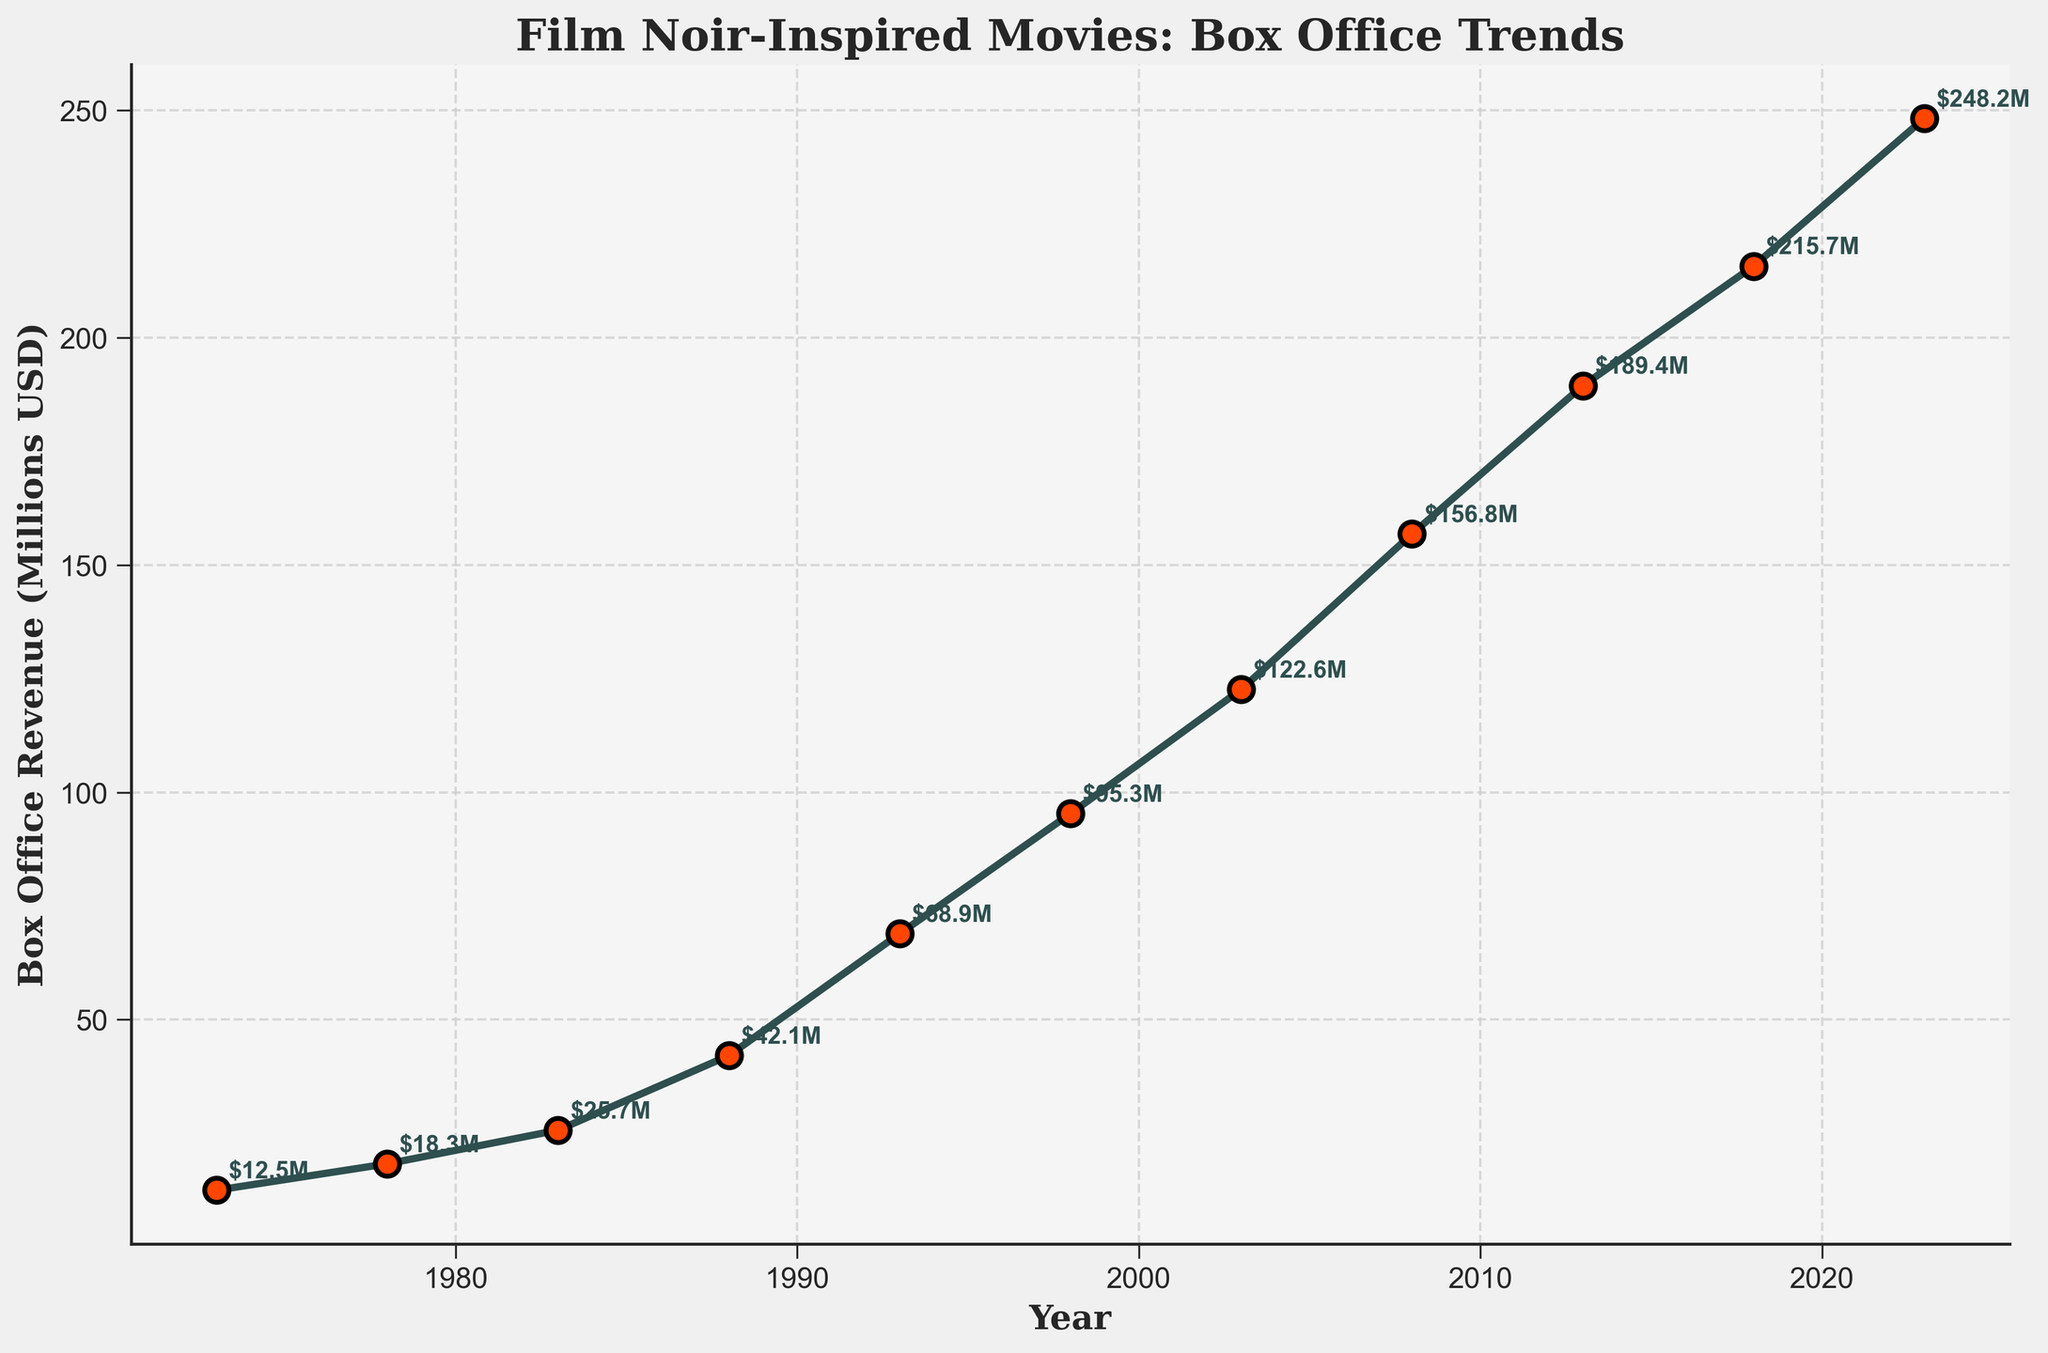What year had the highest box office revenue for film noir-inspired movies? Look at the highest point on the line chart. The highest point corresponds to the year 2023 with a revenue of $248.2M.
Answer: 2023 How much did box office revenue increase from 1973 to 2023? Subtract the box office revenue in 1973 from the revenue in 2023 to find the increase: $248.2M - $12.5M = $235.7M.
Answer: $235.7M Which year had a greater box office revenue, 1988 or 1998? Compare the revenues for the years 1988 and 1998. The revenue in 1988 was $42.1M, while in 1998 it was $95.3M, so 1998 had a greater revenue.
Answer: 1998 What is the average box office revenue for the entire 50-year period? Sum up all the revenue values and divide by the number of years: (12.5 + 18.3 + 25.7 + 42.1 + 68.9 + 95.3 + 122.6 + 156.8 + 189.4 + 215.7 + 248.2) / 11 ≈ $107.6M.
Answer: $107.6M Between which years did the greatest increase in box office revenue occur? Identify the two consecutive years with the largest difference in revenue: The largest increase occurred between 1983 ($25.7M) and 1988 ($42.1M), with an increase of $16.4M.
Answer: 1983 and 1988 What is the median box office revenue for the provided years? List all the revenue values in ascending order and find the middle value. The values are: 12.5, 18.3, 25.7, 42.1, 68.9, 95.3, 122.6, 156.8, 189.4, 215.7, 248.2. The median is the 6th value: $95.3M.
Answer: $95.3M Is there a year where the box office revenue was less than $20M after 1980? Look for any value below $20M after 1980. The lowest revenue after 1980 is in 1983 with $25.7M, so there's no year after 1980 with revenue less than $20M.
Answer: No How does the box office revenue trend between 1993 and 2003 compare to the trend between 2003 and 2013? Calculate the differences in revenue over each period. From 1993 to 2003: $122.6M - $68.9M = $53.7M. From 2003 to 2013: $189.4M - $122.6M = $66.8M. The revenue increase from 2003 to 2013 is higher ($66.8M compared to $53.7M).
Answer: 2003 to 2013 had a higher increase Which year had a box office revenue closest to $100M? Identify the year with the revenue closest to $100M. The closest value is in 1998 with $95.3M.
Answer: 1998 What color are the markers indicating the data points on the plot? According to the visual attributes described, the markers are filled with red and have black edges.
Answer: Red 